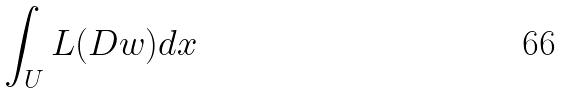Convert formula to latex. <formula><loc_0><loc_0><loc_500><loc_500>\int _ { U } L ( D w ) d x</formula> 